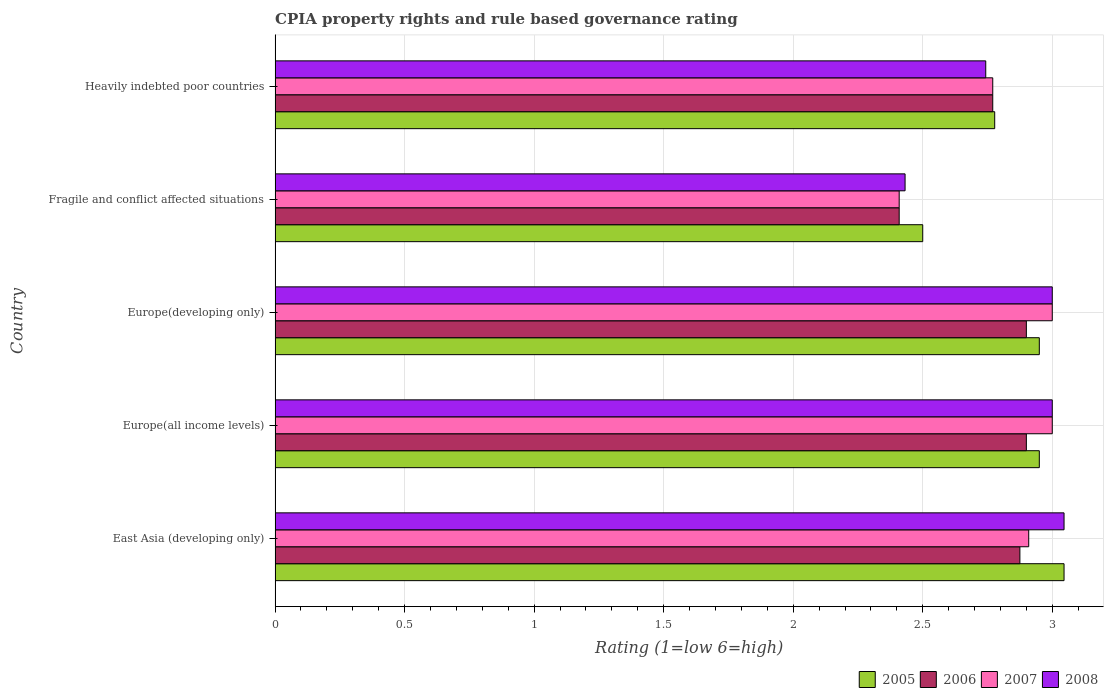Are the number of bars per tick equal to the number of legend labels?
Keep it short and to the point. Yes. Are the number of bars on each tick of the Y-axis equal?
Give a very brief answer. Yes. How many bars are there on the 3rd tick from the top?
Your answer should be very brief. 4. What is the label of the 1st group of bars from the top?
Offer a very short reply. Heavily indebted poor countries. In how many cases, is the number of bars for a given country not equal to the number of legend labels?
Keep it short and to the point. 0. Across all countries, what is the maximum CPIA rating in 2005?
Your answer should be compact. 3.05. In which country was the CPIA rating in 2007 maximum?
Make the answer very short. Europe(all income levels). In which country was the CPIA rating in 2008 minimum?
Your response must be concise. Fragile and conflict affected situations. What is the total CPIA rating in 2006 in the graph?
Make the answer very short. 13.85. What is the difference between the CPIA rating in 2008 in East Asia (developing only) and that in Europe(developing only)?
Provide a short and direct response. 0.05. What is the difference between the CPIA rating in 2006 in Fragile and conflict affected situations and the CPIA rating in 2007 in Europe(all income levels)?
Your answer should be very brief. -0.59. What is the average CPIA rating in 2006 per country?
Give a very brief answer. 2.77. In how many countries, is the CPIA rating in 2006 greater than 1.5 ?
Ensure brevity in your answer.  5. What is the ratio of the CPIA rating in 2006 in East Asia (developing only) to that in Heavily indebted poor countries?
Provide a short and direct response. 1.04. What is the difference between the highest and the lowest CPIA rating in 2006?
Your answer should be compact. 0.49. What does the 4th bar from the top in Europe(all income levels) represents?
Your response must be concise. 2005. What does the 2nd bar from the bottom in Fragile and conflict affected situations represents?
Provide a succinct answer. 2006. Is it the case that in every country, the sum of the CPIA rating in 2006 and CPIA rating in 2007 is greater than the CPIA rating in 2005?
Provide a succinct answer. Yes. How many bars are there?
Offer a terse response. 20. Are all the bars in the graph horizontal?
Give a very brief answer. Yes. How many countries are there in the graph?
Your answer should be compact. 5. Are the values on the major ticks of X-axis written in scientific E-notation?
Ensure brevity in your answer.  No. Does the graph contain any zero values?
Offer a very short reply. No. Does the graph contain grids?
Make the answer very short. Yes. Where does the legend appear in the graph?
Ensure brevity in your answer.  Bottom right. What is the title of the graph?
Offer a terse response. CPIA property rights and rule based governance rating. What is the label or title of the Y-axis?
Your answer should be very brief. Country. What is the Rating (1=low 6=high) of 2005 in East Asia (developing only)?
Your answer should be very brief. 3.05. What is the Rating (1=low 6=high) in 2006 in East Asia (developing only)?
Your response must be concise. 2.88. What is the Rating (1=low 6=high) in 2007 in East Asia (developing only)?
Offer a terse response. 2.91. What is the Rating (1=low 6=high) of 2008 in East Asia (developing only)?
Give a very brief answer. 3.05. What is the Rating (1=low 6=high) in 2005 in Europe(all income levels)?
Offer a very short reply. 2.95. What is the Rating (1=low 6=high) in 2006 in Europe(all income levels)?
Make the answer very short. 2.9. What is the Rating (1=low 6=high) in 2007 in Europe(all income levels)?
Provide a succinct answer. 3. What is the Rating (1=low 6=high) of 2005 in Europe(developing only)?
Your answer should be very brief. 2.95. What is the Rating (1=low 6=high) in 2006 in Europe(developing only)?
Your answer should be compact. 2.9. What is the Rating (1=low 6=high) of 2008 in Europe(developing only)?
Your response must be concise. 3. What is the Rating (1=low 6=high) in 2006 in Fragile and conflict affected situations?
Your response must be concise. 2.41. What is the Rating (1=low 6=high) of 2007 in Fragile and conflict affected situations?
Offer a very short reply. 2.41. What is the Rating (1=low 6=high) in 2008 in Fragile and conflict affected situations?
Provide a short and direct response. 2.43. What is the Rating (1=low 6=high) of 2005 in Heavily indebted poor countries?
Make the answer very short. 2.78. What is the Rating (1=low 6=high) in 2006 in Heavily indebted poor countries?
Provide a short and direct response. 2.77. What is the Rating (1=low 6=high) in 2007 in Heavily indebted poor countries?
Offer a very short reply. 2.77. What is the Rating (1=low 6=high) in 2008 in Heavily indebted poor countries?
Your answer should be very brief. 2.74. Across all countries, what is the maximum Rating (1=low 6=high) of 2005?
Provide a short and direct response. 3.05. Across all countries, what is the maximum Rating (1=low 6=high) in 2006?
Give a very brief answer. 2.9. Across all countries, what is the maximum Rating (1=low 6=high) in 2007?
Provide a short and direct response. 3. Across all countries, what is the maximum Rating (1=low 6=high) in 2008?
Your answer should be compact. 3.05. Across all countries, what is the minimum Rating (1=low 6=high) in 2005?
Offer a very short reply. 2.5. Across all countries, what is the minimum Rating (1=low 6=high) in 2006?
Offer a very short reply. 2.41. Across all countries, what is the minimum Rating (1=low 6=high) of 2007?
Make the answer very short. 2.41. Across all countries, what is the minimum Rating (1=low 6=high) in 2008?
Provide a short and direct response. 2.43. What is the total Rating (1=low 6=high) of 2005 in the graph?
Provide a short and direct response. 14.22. What is the total Rating (1=low 6=high) of 2006 in the graph?
Offer a very short reply. 13.85. What is the total Rating (1=low 6=high) in 2007 in the graph?
Offer a terse response. 14.09. What is the total Rating (1=low 6=high) of 2008 in the graph?
Your answer should be compact. 14.22. What is the difference between the Rating (1=low 6=high) of 2005 in East Asia (developing only) and that in Europe(all income levels)?
Give a very brief answer. 0.1. What is the difference between the Rating (1=low 6=high) of 2006 in East Asia (developing only) and that in Europe(all income levels)?
Ensure brevity in your answer.  -0.03. What is the difference between the Rating (1=low 6=high) of 2007 in East Asia (developing only) and that in Europe(all income levels)?
Your answer should be very brief. -0.09. What is the difference between the Rating (1=low 6=high) of 2008 in East Asia (developing only) and that in Europe(all income levels)?
Provide a succinct answer. 0.05. What is the difference between the Rating (1=low 6=high) in 2005 in East Asia (developing only) and that in Europe(developing only)?
Make the answer very short. 0.1. What is the difference between the Rating (1=low 6=high) of 2006 in East Asia (developing only) and that in Europe(developing only)?
Your answer should be very brief. -0.03. What is the difference between the Rating (1=low 6=high) in 2007 in East Asia (developing only) and that in Europe(developing only)?
Provide a succinct answer. -0.09. What is the difference between the Rating (1=low 6=high) in 2008 in East Asia (developing only) and that in Europe(developing only)?
Offer a terse response. 0.05. What is the difference between the Rating (1=low 6=high) of 2005 in East Asia (developing only) and that in Fragile and conflict affected situations?
Provide a succinct answer. 0.55. What is the difference between the Rating (1=low 6=high) in 2006 in East Asia (developing only) and that in Fragile and conflict affected situations?
Provide a succinct answer. 0.47. What is the difference between the Rating (1=low 6=high) in 2008 in East Asia (developing only) and that in Fragile and conflict affected situations?
Give a very brief answer. 0.61. What is the difference between the Rating (1=low 6=high) in 2005 in East Asia (developing only) and that in Heavily indebted poor countries?
Provide a short and direct response. 0.27. What is the difference between the Rating (1=low 6=high) in 2006 in East Asia (developing only) and that in Heavily indebted poor countries?
Ensure brevity in your answer.  0.1. What is the difference between the Rating (1=low 6=high) in 2007 in East Asia (developing only) and that in Heavily indebted poor countries?
Ensure brevity in your answer.  0.14. What is the difference between the Rating (1=low 6=high) of 2008 in East Asia (developing only) and that in Heavily indebted poor countries?
Ensure brevity in your answer.  0.3. What is the difference between the Rating (1=low 6=high) of 2005 in Europe(all income levels) and that in Europe(developing only)?
Keep it short and to the point. 0. What is the difference between the Rating (1=low 6=high) of 2008 in Europe(all income levels) and that in Europe(developing only)?
Make the answer very short. 0. What is the difference between the Rating (1=low 6=high) of 2005 in Europe(all income levels) and that in Fragile and conflict affected situations?
Offer a terse response. 0.45. What is the difference between the Rating (1=low 6=high) of 2006 in Europe(all income levels) and that in Fragile and conflict affected situations?
Offer a very short reply. 0.49. What is the difference between the Rating (1=low 6=high) of 2007 in Europe(all income levels) and that in Fragile and conflict affected situations?
Keep it short and to the point. 0.59. What is the difference between the Rating (1=low 6=high) of 2008 in Europe(all income levels) and that in Fragile and conflict affected situations?
Offer a terse response. 0.57. What is the difference between the Rating (1=low 6=high) in 2005 in Europe(all income levels) and that in Heavily indebted poor countries?
Keep it short and to the point. 0.17. What is the difference between the Rating (1=low 6=high) of 2006 in Europe(all income levels) and that in Heavily indebted poor countries?
Your response must be concise. 0.13. What is the difference between the Rating (1=low 6=high) of 2007 in Europe(all income levels) and that in Heavily indebted poor countries?
Offer a very short reply. 0.23. What is the difference between the Rating (1=low 6=high) of 2008 in Europe(all income levels) and that in Heavily indebted poor countries?
Offer a very short reply. 0.26. What is the difference between the Rating (1=low 6=high) in 2005 in Europe(developing only) and that in Fragile and conflict affected situations?
Your answer should be very brief. 0.45. What is the difference between the Rating (1=low 6=high) of 2006 in Europe(developing only) and that in Fragile and conflict affected situations?
Make the answer very short. 0.49. What is the difference between the Rating (1=low 6=high) of 2007 in Europe(developing only) and that in Fragile and conflict affected situations?
Make the answer very short. 0.59. What is the difference between the Rating (1=low 6=high) of 2008 in Europe(developing only) and that in Fragile and conflict affected situations?
Your answer should be compact. 0.57. What is the difference between the Rating (1=low 6=high) of 2005 in Europe(developing only) and that in Heavily indebted poor countries?
Provide a short and direct response. 0.17. What is the difference between the Rating (1=low 6=high) in 2006 in Europe(developing only) and that in Heavily indebted poor countries?
Your answer should be very brief. 0.13. What is the difference between the Rating (1=low 6=high) in 2007 in Europe(developing only) and that in Heavily indebted poor countries?
Keep it short and to the point. 0.23. What is the difference between the Rating (1=low 6=high) of 2008 in Europe(developing only) and that in Heavily indebted poor countries?
Your answer should be compact. 0.26. What is the difference between the Rating (1=low 6=high) of 2005 in Fragile and conflict affected situations and that in Heavily indebted poor countries?
Give a very brief answer. -0.28. What is the difference between the Rating (1=low 6=high) of 2006 in Fragile and conflict affected situations and that in Heavily indebted poor countries?
Your response must be concise. -0.36. What is the difference between the Rating (1=low 6=high) in 2007 in Fragile and conflict affected situations and that in Heavily indebted poor countries?
Keep it short and to the point. -0.36. What is the difference between the Rating (1=low 6=high) in 2008 in Fragile and conflict affected situations and that in Heavily indebted poor countries?
Ensure brevity in your answer.  -0.31. What is the difference between the Rating (1=low 6=high) in 2005 in East Asia (developing only) and the Rating (1=low 6=high) in 2006 in Europe(all income levels)?
Give a very brief answer. 0.15. What is the difference between the Rating (1=low 6=high) of 2005 in East Asia (developing only) and the Rating (1=low 6=high) of 2007 in Europe(all income levels)?
Provide a succinct answer. 0.05. What is the difference between the Rating (1=low 6=high) in 2005 in East Asia (developing only) and the Rating (1=low 6=high) in 2008 in Europe(all income levels)?
Give a very brief answer. 0.05. What is the difference between the Rating (1=low 6=high) of 2006 in East Asia (developing only) and the Rating (1=low 6=high) of 2007 in Europe(all income levels)?
Your answer should be compact. -0.12. What is the difference between the Rating (1=low 6=high) in 2006 in East Asia (developing only) and the Rating (1=low 6=high) in 2008 in Europe(all income levels)?
Offer a very short reply. -0.12. What is the difference between the Rating (1=low 6=high) of 2007 in East Asia (developing only) and the Rating (1=low 6=high) of 2008 in Europe(all income levels)?
Keep it short and to the point. -0.09. What is the difference between the Rating (1=low 6=high) of 2005 in East Asia (developing only) and the Rating (1=low 6=high) of 2006 in Europe(developing only)?
Ensure brevity in your answer.  0.15. What is the difference between the Rating (1=low 6=high) in 2005 in East Asia (developing only) and the Rating (1=low 6=high) in 2007 in Europe(developing only)?
Ensure brevity in your answer.  0.05. What is the difference between the Rating (1=low 6=high) of 2005 in East Asia (developing only) and the Rating (1=low 6=high) of 2008 in Europe(developing only)?
Provide a short and direct response. 0.05. What is the difference between the Rating (1=low 6=high) in 2006 in East Asia (developing only) and the Rating (1=low 6=high) in 2007 in Europe(developing only)?
Keep it short and to the point. -0.12. What is the difference between the Rating (1=low 6=high) of 2006 in East Asia (developing only) and the Rating (1=low 6=high) of 2008 in Europe(developing only)?
Your answer should be very brief. -0.12. What is the difference between the Rating (1=low 6=high) of 2007 in East Asia (developing only) and the Rating (1=low 6=high) of 2008 in Europe(developing only)?
Your response must be concise. -0.09. What is the difference between the Rating (1=low 6=high) of 2005 in East Asia (developing only) and the Rating (1=low 6=high) of 2006 in Fragile and conflict affected situations?
Provide a succinct answer. 0.64. What is the difference between the Rating (1=low 6=high) of 2005 in East Asia (developing only) and the Rating (1=low 6=high) of 2007 in Fragile and conflict affected situations?
Provide a short and direct response. 0.64. What is the difference between the Rating (1=low 6=high) in 2005 in East Asia (developing only) and the Rating (1=low 6=high) in 2008 in Fragile and conflict affected situations?
Ensure brevity in your answer.  0.61. What is the difference between the Rating (1=low 6=high) of 2006 in East Asia (developing only) and the Rating (1=low 6=high) of 2007 in Fragile and conflict affected situations?
Provide a succinct answer. 0.47. What is the difference between the Rating (1=low 6=high) of 2006 in East Asia (developing only) and the Rating (1=low 6=high) of 2008 in Fragile and conflict affected situations?
Offer a terse response. 0.44. What is the difference between the Rating (1=low 6=high) of 2007 in East Asia (developing only) and the Rating (1=low 6=high) of 2008 in Fragile and conflict affected situations?
Provide a succinct answer. 0.48. What is the difference between the Rating (1=low 6=high) in 2005 in East Asia (developing only) and the Rating (1=low 6=high) in 2006 in Heavily indebted poor countries?
Make the answer very short. 0.28. What is the difference between the Rating (1=low 6=high) of 2005 in East Asia (developing only) and the Rating (1=low 6=high) of 2007 in Heavily indebted poor countries?
Offer a very short reply. 0.28. What is the difference between the Rating (1=low 6=high) of 2005 in East Asia (developing only) and the Rating (1=low 6=high) of 2008 in Heavily indebted poor countries?
Ensure brevity in your answer.  0.3. What is the difference between the Rating (1=low 6=high) of 2006 in East Asia (developing only) and the Rating (1=low 6=high) of 2007 in Heavily indebted poor countries?
Give a very brief answer. 0.1. What is the difference between the Rating (1=low 6=high) in 2006 in East Asia (developing only) and the Rating (1=low 6=high) in 2008 in Heavily indebted poor countries?
Keep it short and to the point. 0.13. What is the difference between the Rating (1=low 6=high) of 2007 in East Asia (developing only) and the Rating (1=low 6=high) of 2008 in Heavily indebted poor countries?
Provide a succinct answer. 0.17. What is the difference between the Rating (1=low 6=high) of 2005 in Europe(all income levels) and the Rating (1=low 6=high) of 2006 in Europe(developing only)?
Provide a succinct answer. 0.05. What is the difference between the Rating (1=low 6=high) in 2005 in Europe(all income levels) and the Rating (1=low 6=high) in 2007 in Europe(developing only)?
Provide a short and direct response. -0.05. What is the difference between the Rating (1=low 6=high) in 2006 in Europe(all income levels) and the Rating (1=low 6=high) in 2008 in Europe(developing only)?
Your response must be concise. -0.1. What is the difference between the Rating (1=low 6=high) of 2007 in Europe(all income levels) and the Rating (1=low 6=high) of 2008 in Europe(developing only)?
Offer a terse response. 0. What is the difference between the Rating (1=low 6=high) of 2005 in Europe(all income levels) and the Rating (1=low 6=high) of 2006 in Fragile and conflict affected situations?
Offer a terse response. 0.54. What is the difference between the Rating (1=low 6=high) in 2005 in Europe(all income levels) and the Rating (1=low 6=high) in 2007 in Fragile and conflict affected situations?
Your response must be concise. 0.54. What is the difference between the Rating (1=low 6=high) in 2005 in Europe(all income levels) and the Rating (1=low 6=high) in 2008 in Fragile and conflict affected situations?
Make the answer very short. 0.52. What is the difference between the Rating (1=low 6=high) in 2006 in Europe(all income levels) and the Rating (1=low 6=high) in 2007 in Fragile and conflict affected situations?
Make the answer very short. 0.49. What is the difference between the Rating (1=low 6=high) in 2006 in Europe(all income levels) and the Rating (1=low 6=high) in 2008 in Fragile and conflict affected situations?
Provide a short and direct response. 0.47. What is the difference between the Rating (1=low 6=high) in 2007 in Europe(all income levels) and the Rating (1=low 6=high) in 2008 in Fragile and conflict affected situations?
Provide a succinct answer. 0.57. What is the difference between the Rating (1=low 6=high) of 2005 in Europe(all income levels) and the Rating (1=low 6=high) of 2006 in Heavily indebted poor countries?
Offer a very short reply. 0.18. What is the difference between the Rating (1=low 6=high) in 2005 in Europe(all income levels) and the Rating (1=low 6=high) in 2007 in Heavily indebted poor countries?
Make the answer very short. 0.18. What is the difference between the Rating (1=low 6=high) in 2005 in Europe(all income levels) and the Rating (1=low 6=high) in 2008 in Heavily indebted poor countries?
Your answer should be compact. 0.21. What is the difference between the Rating (1=low 6=high) of 2006 in Europe(all income levels) and the Rating (1=low 6=high) of 2007 in Heavily indebted poor countries?
Your answer should be compact. 0.13. What is the difference between the Rating (1=low 6=high) in 2006 in Europe(all income levels) and the Rating (1=low 6=high) in 2008 in Heavily indebted poor countries?
Your response must be concise. 0.16. What is the difference between the Rating (1=low 6=high) of 2007 in Europe(all income levels) and the Rating (1=low 6=high) of 2008 in Heavily indebted poor countries?
Keep it short and to the point. 0.26. What is the difference between the Rating (1=low 6=high) of 2005 in Europe(developing only) and the Rating (1=low 6=high) of 2006 in Fragile and conflict affected situations?
Make the answer very short. 0.54. What is the difference between the Rating (1=low 6=high) of 2005 in Europe(developing only) and the Rating (1=low 6=high) of 2007 in Fragile and conflict affected situations?
Offer a terse response. 0.54. What is the difference between the Rating (1=low 6=high) in 2005 in Europe(developing only) and the Rating (1=low 6=high) in 2008 in Fragile and conflict affected situations?
Keep it short and to the point. 0.52. What is the difference between the Rating (1=low 6=high) of 2006 in Europe(developing only) and the Rating (1=low 6=high) of 2007 in Fragile and conflict affected situations?
Your answer should be compact. 0.49. What is the difference between the Rating (1=low 6=high) in 2006 in Europe(developing only) and the Rating (1=low 6=high) in 2008 in Fragile and conflict affected situations?
Your response must be concise. 0.47. What is the difference between the Rating (1=low 6=high) in 2007 in Europe(developing only) and the Rating (1=low 6=high) in 2008 in Fragile and conflict affected situations?
Ensure brevity in your answer.  0.57. What is the difference between the Rating (1=low 6=high) of 2005 in Europe(developing only) and the Rating (1=low 6=high) of 2006 in Heavily indebted poor countries?
Provide a short and direct response. 0.18. What is the difference between the Rating (1=low 6=high) of 2005 in Europe(developing only) and the Rating (1=low 6=high) of 2007 in Heavily indebted poor countries?
Give a very brief answer. 0.18. What is the difference between the Rating (1=low 6=high) of 2005 in Europe(developing only) and the Rating (1=low 6=high) of 2008 in Heavily indebted poor countries?
Make the answer very short. 0.21. What is the difference between the Rating (1=low 6=high) in 2006 in Europe(developing only) and the Rating (1=low 6=high) in 2007 in Heavily indebted poor countries?
Keep it short and to the point. 0.13. What is the difference between the Rating (1=low 6=high) of 2006 in Europe(developing only) and the Rating (1=low 6=high) of 2008 in Heavily indebted poor countries?
Your answer should be compact. 0.16. What is the difference between the Rating (1=low 6=high) of 2007 in Europe(developing only) and the Rating (1=low 6=high) of 2008 in Heavily indebted poor countries?
Provide a succinct answer. 0.26. What is the difference between the Rating (1=low 6=high) in 2005 in Fragile and conflict affected situations and the Rating (1=low 6=high) in 2006 in Heavily indebted poor countries?
Provide a succinct answer. -0.27. What is the difference between the Rating (1=low 6=high) in 2005 in Fragile and conflict affected situations and the Rating (1=low 6=high) in 2007 in Heavily indebted poor countries?
Keep it short and to the point. -0.27. What is the difference between the Rating (1=low 6=high) of 2005 in Fragile and conflict affected situations and the Rating (1=low 6=high) of 2008 in Heavily indebted poor countries?
Your response must be concise. -0.24. What is the difference between the Rating (1=low 6=high) in 2006 in Fragile and conflict affected situations and the Rating (1=low 6=high) in 2007 in Heavily indebted poor countries?
Ensure brevity in your answer.  -0.36. What is the difference between the Rating (1=low 6=high) of 2006 in Fragile and conflict affected situations and the Rating (1=low 6=high) of 2008 in Heavily indebted poor countries?
Ensure brevity in your answer.  -0.33. What is the difference between the Rating (1=low 6=high) of 2007 in Fragile and conflict affected situations and the Rating (1=low 6=high) of 2008 in Heavily indebted poor countries?
Make the answer very short. -0.33. What is the average Rating (1=low 6=high) of 2005 per country?
Make the answer very short. 2.84. What is the average Rating (1=low 6=high) in 2006 per country?
Ensure brevity in your answer.  2.77. What is the average Rating (1=low 6=high) in 2007 per country?
Offer a terse response. 2.82. What is the average Rating (1=low 6=high) in 2008 per country?
Offer a terse response. 2.84. What is the difference between the Rating (1=low 6=high) in 2005 and Rating (1=low 6=high) in 2006 in East Asia (developing only)?
Keep it short and to the point. 0.17. What is the difference between the Rating (1=low 6=high) of 2005 and Rating (1=low 6=high) of 2007 in East Asia (developing only)?
Make the answer very short. 0.14. What is the difference between the Rating (1=low 6=high) of 2005 and Rating (1=low 6=high) of 2008 in East Asia (developing only)?
Provide a succinct answer. 0. What is the difference between the Rating (1=low 6=high) of 2006 and Rating (1=low 6=high) of 2007 in East Asia (developing only)?
Your answer should be compact. -0.03. What is the difference between the Rating (1=low 6=high) of 2006 and Rating (1=low 6=high) of 2008 in East Asia (developing only)?
Ensure brevity in your answer.  -0.17. What is the difference between the Rating (1=low 6=high) of 2007 and Rating (1=low 6=high) of 2008 in East Asia (developing only)?
Provide a short and direct response. -0.14. What is the difference between the Rating (1=low 6=high) in 2005 and Rating (1=low 6=high) in 2008 in Europe(all income levels)?
Ensure brevity in your answer.  -0.05. What is the difference between the Rating (1=low 6=high) in 2006 and Rating (1=low 6=high) in 2007 in Europe(all income levels)?
Provide a succinct answer. -0.1. What is the difference between the Rating (1=low 6=high) of 2006 and Rating (1=low 6=high) of 2008 in Europe(all income levels)?
Make the answer very short. -0.1. What is the difference between the Rating (1=low 6=high) of 2007 and Rating (1=low 6=high) of 2008 in Europe(all income levels)?
Your answer should be compact. 0. What is the difference between the Rating (1=low 6=high) of 2005 and Rating (1=low 6=high) of 2007 in Europe(developing only)?
Make the answer very short. -0.05. What is the difference between the Rating (1=low 6=high) in 2006 and Rating (1=low 6=high) in 2007 in Europe(developing only)?
Give a very brief answer. -0.1. What is the difference between the Rating (1=low 6=high) of 2007 and Rating (1=low 6=high) of 2008 in Europe(developing only)?
Ensure brevity in your answer.  0. What is the difference between the Rating (1=low 6=high) of 2005 and Rating (1=low 6=high) of 2006 in Fragile and conflict affected situations?
Your answer should be compact. 0.09. What is the difference between the Rating (1=low 6=high) of 2005 and Rating (1=low 6=high) of 2007 in Fragile and conflict affected situations?
Make the answer very short. 0.09. What is the difference between the Rating (1=low 6=high) of 2005 and Rating (1=low 6=high) of 2008 in Fragile and conflict affected situations?
Make the answer very short. 0.07. What is the difference between the Rating (1=low 6=high) of 2006 and Rating (1=low 6=high) of 2007 in Fragile and conflict affected situations?
Make the answer very short. 0. What is the difference between the Rating (1=low 6=high) in 2006 and Rating (1=low 6=high) in 2008 in Fragile and conflict affected situations?
Your response must be concise. -0.02. What is the difference between the Rating (1=low 6=high) in 2007 and Rating (1=low 6=high) in 2008 in Fragile and conflict affected situations?
Offer a terse response. -0.02. What is the difference between the Rating (1=low 6=high) in 2005 and Rating (1=low 6=high) in 2006 in Heavily indebted poor countries?
Make the answer very short. 0.01. What is the difference between the Rating (1=low 6=high) in 2005 and Rating (1=low 6=high) in 2007 in Heavily indebted poor countries?
Give a very brief answer. 0.01. What is the difference between the Rating (1=low 6=high) of 2005 and Rating (1=low 6=high) of 2008 in Heavily indebted poor countries?
Keep it short and to the point. 0.03. What is the difference between the Rating (1=low 6=high) in 2006 and Rating (1=low 6=high) in 2008 in Heavily indebted poor countries?
Your answer should be compact. 0.03. What is the difference between the Rating (1=low 6=high) in 2007 and Rating (1=low 6=high) in 2008 in Heavily indebted poor countries?
Your answer should be very brief. 0.03. What is the ratio of the Rating (1=low 6=high) in 2005 in East Asia (developing only) to that in Europe(all income levels)?
Make the answer very short. 1.03. What is the ratio of the Rating (1=low 6=high) of 2006 in East Asia (developing only) to that in Europe(all income levels)?
Give a very brief answer. 0.99. What is the ratio of the Rating (1=low 6=high) in 2007 in East Asia (developing only) to that in Europe(all income levels)?
Provide a succinct answer. 0.97. What is the ratio of the Rating (1=low 6=high) in 2008 in East Asia (developing only) to that in Europe(all income levels)?
Your answer should be very brief. 1.02. What is the ratio of the Rating (1=low 6=high) of 2005 in East Asia (developing only) to that in Europe(developing only)?
Keep it short and to the point. 1.03. What is the ratio of the Rating (1=low 6=high) of 2006 in East Asia (developing only) to that in Europe(developing only)?
Your answer should be compact. 0.99. What is the ratio of the Rating (1=low 6=high) of 2007 in East Asia (developing only) to that in Europe(developing only)?
Provide a short and direct response. 0.97. What is the ratio of the Rating (1=low 6=high) in 2008 in East Asia (developing only) to that in Europe(developing only)?
Keep it short and to the point. 1.02. What is the ratio of the Rating (1=low 6=high) of 2005 in East Asia (developing only) to that in Fragile and conflict affected situations?
Offer a terse response. 1.22. What is the ratio of the Rating (1=low 6=high) in 2006 in East Asia (developing only) to that in Fragile and conflict affected situations?
Offer a terse response. 1.19. What is the ratio of the Rating (1=low 6=high) of 2007 in East Asia (developing only) to that in Fragile and conflict affected situations?
Give a very brief answer. 1.21. What is the ratio of the Rating (1=low 6=high) in 2008 in East Asia (developing only) to that in Fragile and conflict affected situations?
Provide a succinct answer. 1.25. What is the ratio of the Rating (1=low 6=high) in 2005 in East Asia (developing only) to that in Heavily indebted poor countries?
Give a very brief answer. 1.1. What is the ratio of the Rating (1=low 6=high) in 2006 in East Asia (developing only) to that in Heavily indebted poor countries?
Your answer should be compact. 1.04. What is the ratio of the Rating (1=low 6=high) in 2007 in East Asia (developing only) to that in Heavily indebted poor countries?
Keep it short and to the point. 1.05. What is the ratio of the Rating (1=low 6=high) in 2008 in East Asia (developing only) to that in Heavily indebted poor countries?
Provide a succinct answer. 1.11. What is the ratio of the Rating (1=low 6=high) in 2005 in Europe(all income levels) to that in Europe(developing only)?
Your answer should be compact. 1. What is the ratio of the Rating (1=low 6=high) in 2008 in Europe(all income levels) to that in Europe(developing only)?
Provide a short and direct response. 1. What is the ratio of the Rating (1=low 6=high) in 2005 in Europe(all income levels) to that in Fragile and conflict affected situations?
Your answer should be very brief. 1.18. What is the ratio of the Rating (1=low 6=high) in 2006 in Europe(all income levels) to that in Fragile and conflict affected situations?
Ensure brevity in your answer.  1.2. What is the ratio of the Rating (1=low 6=high) in 2007 in Europe(all income levels) to that in Fragile and conflict affected situations?
Keep it short and to the point. 1.25. What is the ratio of the Rating (1=low 6=high) of 2008 in Europe(all income levels) to that in Fragile and conflict affected situations?
Make the answer very short. 1.23. What is the ratio of the Rating (1=low 6=high) in 2005 in Europe(all income levels) to that in Heavily indebted poor countries?
Your response must be concise. 1.06. What is the ratio of the Rating (1=low 6=high) of 2006 in Europe(all income levels) to that in Heavily indebted poor countries?
Your answer should be compact. 1.05. What is the ratio of the Rating (1=low 6=high) of 2007 in Europe(all income levels) to that in Heavily indebted poor countries?
Your answer should be compact. 1.08. What is the ratio of the Rating (1=low 6=high) in 2008 in Europe(all income levels) to that in Heavily indebted poor countries?
Offer a terse response. 1.09. What is the ratio of the Rating (1=low 6=high) in 2005 in Europe(developing only) to that in Fragile and conflict affected situations?
Your answer should be compact. 1.18. What is the ratio of the Rating (1=low 6=high) of 2006 in Europe(developing only) to that in Fragile and conflict affected situations?
Keep it short and to the point. 1.2. What is the ratio of the Rating (1=low 6=high) of 2007 in Europe(developing only) to that in Fragile and conflict affected situations?
Keep it short and to the point. 1.25. What is the ratio of the Rating (1=low 6=high) in 2008 in Europe(developing only) to that in Fragile and conflict affected situations?
Offer a very short reply. 1.23. What is the ratio of the Rating (1=low 6=high) in 2005 in Europe(developing only) to that in Heavily indebted poor countries?
Your response must be concise. 1.06. What is the ratio of the Rating (1=low 6=high) in 2006 in Europe(developing only) to that in Heavily indebted poor countries?
Offer a very short reply. 1.05. What is the ratio of the Rating (1=low 6=high) in 2007 in Europe(developing only) to that in Heavily indebted poor countries?
Keep it short and to the point. 1.08. What is the ratio of the Rating (1=low 6=high) in 2008 in Europe(developing only) to that in Heavily indebted poor countries?
Your response must be concise. 1.09. What is the ratio of the Rating (1=low 6=high) of 2005 in Fragile and conflict affected situations to that in Heavily indebted poor countries?
Provide a short and direct response. 0.9. What is the ratio of the Rating (1=low 6=high) of 2006 in Fragile and conflict affected situations to that in Heavily indebted poor countries?
Your answer should be compact. 0.87. What is the ratio of the Rating (1=low 6=high) of 2007 in Fragile and conflict affected situations to that in Heavily indebted poor countries?
Make the answer very short. 0.87. What is the ratio of the Rating (1=low 6=high) of 2008 in Fragile and conflict affected situations to that in Heavily indebted poor countries?
Your answer should be very brief. 0.89. What is the difference between the highest and the second highest Rating (1=low 6=high) of 2005?
Ensure brevity in your answer.  0.1. What is the difference between the highest and the second highest Rating (1=low 6=high) in 2007?
Keep it short and to the point. 0. What is the difference between the highest and the second highest Rating (1=low 6=high) in 2008?
Provide a succinct answer. 0.05. What is the difference between the highest and the lowest Rating (1=low 6=high) in 2005?
Your response must be concise. 0.55. What is the difference between the highest and the lowest Rating (1=low 6=high) in 2006?
Offer a terse response. 0.49. What is the difference between the highest and the lowest Rating (1=low 6=high) of 2007?
Offer a very short reply. 0.59. What is the difference between the highest and the lowest Rating (1=low 6=high) in 2008?
Give a very brief answer. 0.61. 